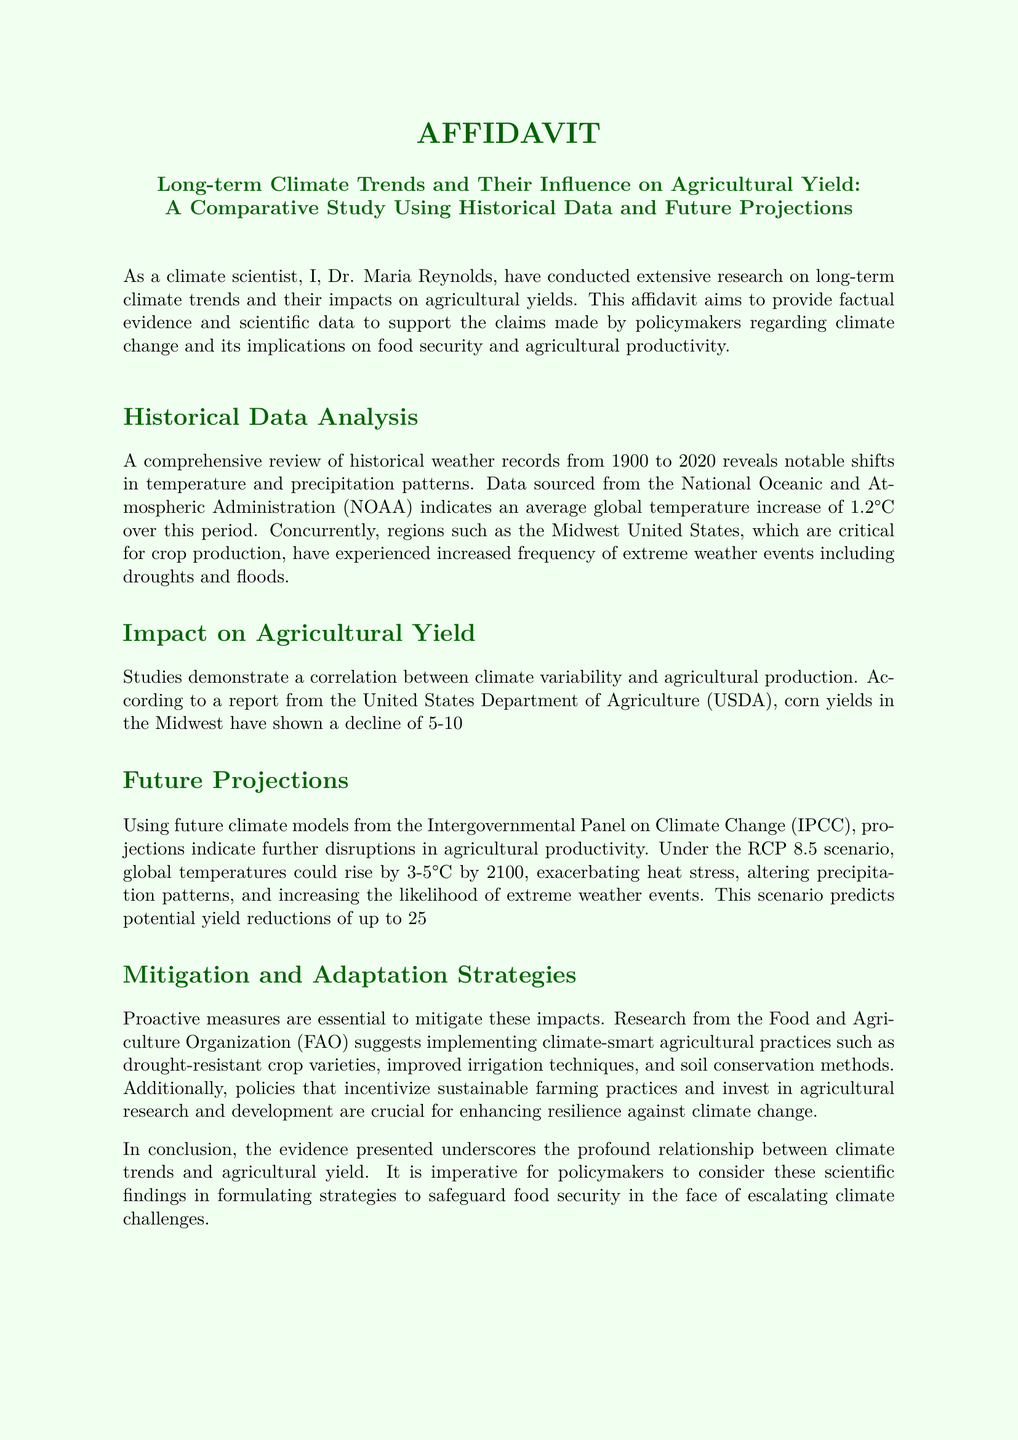what is the average global temperature increase reported in the affidavit? The affidavit states that the average global temperature increase is 1.2°C over the period from 1900 to 2020.
Answer: 1.2°C who conducted the research mentioned in the affidavit? The author of the affidavit, Dr. Maria Reynolds, conducted the research on long-term climate trends and their impacts on agricultural yields.
Answer: Dr. Maria Reynolds what year does the historical data analysis cover? The affidavit mentions that the historical weather records cover the period from 1900 to 2020.
Answer: 1900 to 2020 what is the predicted temperature rise under the RCP 8.5 scenario by 2100? The document predicts that under the RCP 8.5 scenario, global temperatures could rise by 3-5°C by 2100.
Answer: 3-5°C what percentage decline in corn yields is reported during periods of severe drought? According to the United States Department of Agriculture (USDA), corn yields in the Midwest have shown a decline of 5-10% during severe drought periods.
Answer: 5-10% which organization provided the report stating the wheat yield reduction in India? The International Food Policy Research Institute (IFPRI) provided the report on the 15% reduction in wheat yield in India.
Answer: International Food Policy Research Institute (IFPRI) what is one climate-smart agricultural practice suggested in the affidavit? The affidavit suggests implementing drought-resistant crop varieties as one of the climate-smart agricultural practices.
Answer: drought-resistant crop varieties when was the affidavit signed? The affidavit was signed on October 3, 2023.
Answer: October 3, 2023 